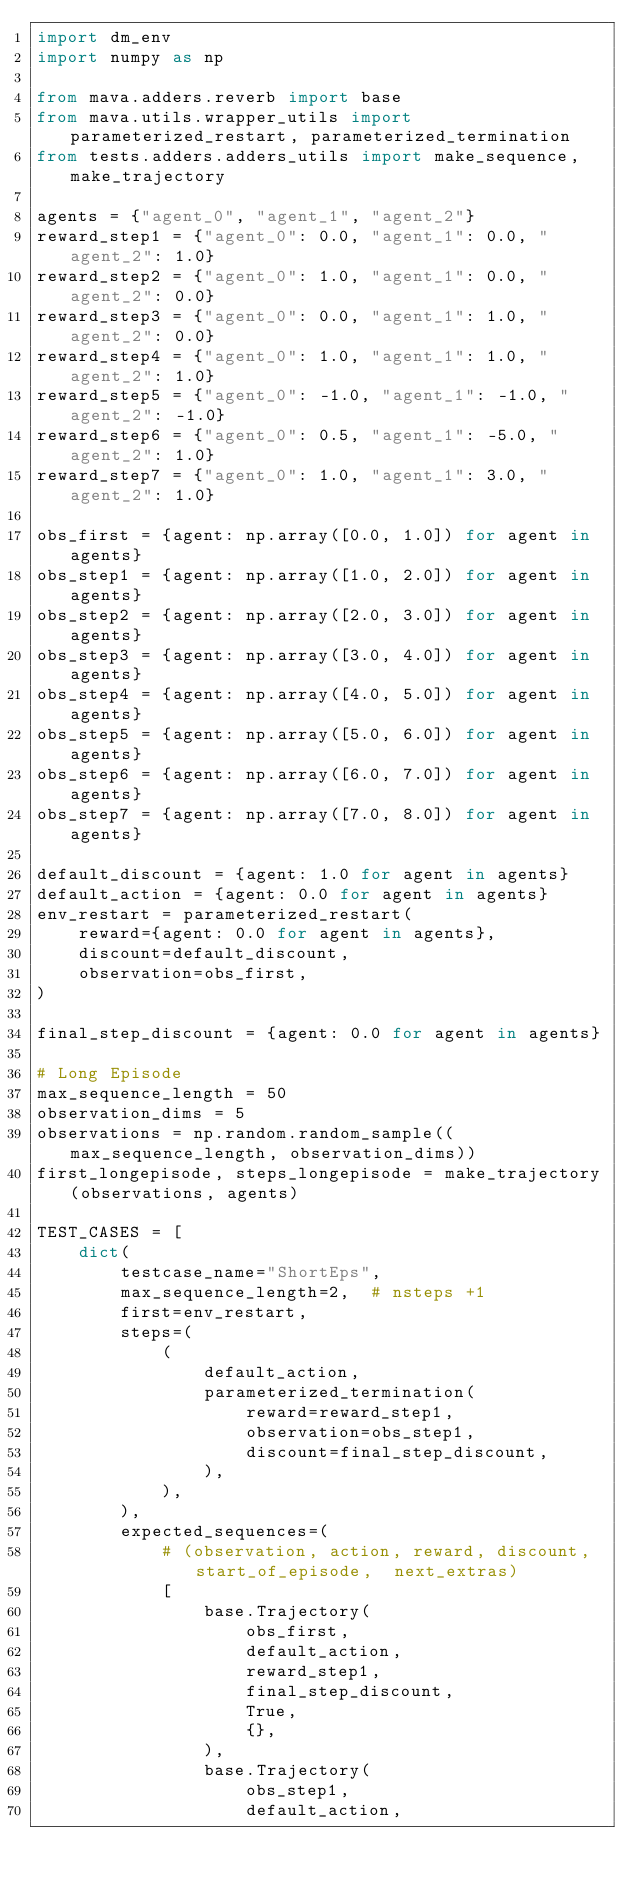Convert code to text. <code><loc_0><loc_0><loc_500><loc_500><_Python_>import dm_env
import numpy as np

from mava.adders.reverb import base
from mava.utils.wrapper_utils import parameterized_restart, parameterized_termination
from tests.adders.adders_utils import make_sequence, make_trajectory

agents = {"agent_0", "agent_1", "agent_2"}
reward_step1 = {"agent_0": 0.0, "agent_1": 0.0, "agent_2": 1.0}
reward_step2 = {"agent_0": 1.0, "agent_1": 0.0, "agent_2": 0.0}
reward_step3 = {"agent_0": 0.0, "agent_1": 1.0, "agent_2": 0.0}
reward_step4 = {"agent_0": 1.0, "agent_1": 1.0, "agent_2": 1.0}
reward_step5 = {"agent_0": -1.0, "agent_1": -1.0, "agent_2": -1.0}
reward_step6 = {"agent_0": 0.5, "agent_1": -5.0, "agent_2": 1.0}
reward_step7 = {"agent_0": 1.0, "agent_1": 3.0, "agent_2": 1.0}

obs_first = {agent: np.array([0.0, 1.0]) for agent in agents}
obs_step1 = {agent: np.array([1.0, 2.0]) for agent in agents}
obs_step2 = {agent: np.array([2.0, 3.0]) for agent in agents}
obs_step3 = {agent: np.array([3.0, 4.0]) for agent in agents}
obs_step4 = {agent: np.array([4.0, 5.0]) for agent in agents}
obs_step5 = {agent: np.array([5.0, 6.0]) for agent in agents}
obs_step6 = {agent: np.array([6.0, 7.0]) for agent in agents}
obs_step7 = {agent: np.array([7.0, 8.0]) for agent in agents}

default_discount = {agent: 1.0 for agent in agents}
default_action = {agent: 0.0 for agent in agents}
env_restart = parameterized_restart(
    reward={agent: 0.0 for agent in agents},
    discount=default_discount,
    observation=obs_first,
)

final_step_discount = {agent: 0.0 for agent in agents}

# Long Episode
max_sequence_length = 50
observation_dims = 5
observations = np.random.random_sample((max_sequence_length, observation_dims))
first_longepisode, steps_longepisode = make_trajectory(observations, agents)

TEST_CASES = [
    dict(
        testcase_name="ShortEps",
        max_sequence_length=2,  # nsteps +1
        first=env_restart,
        steps=(
            (
                default_action,
                parameterized_termination(
                    reward=reward_step1,
                    observation=obs_step1,
                    discount=final_step_discount,
                ),
            ),
        ),
        expected_sequences=(
            # (observation, action, reward, discount, start_of_episode,  next_extras)
            [
                base.Trajectory(
                    obs_first,
                    default_action,
                    reward_step1,
                    final_step_discount,
                    True,
                    {},
                ),
                base.Trajectory(
                    obs_step1,
                    default_action,</code> 